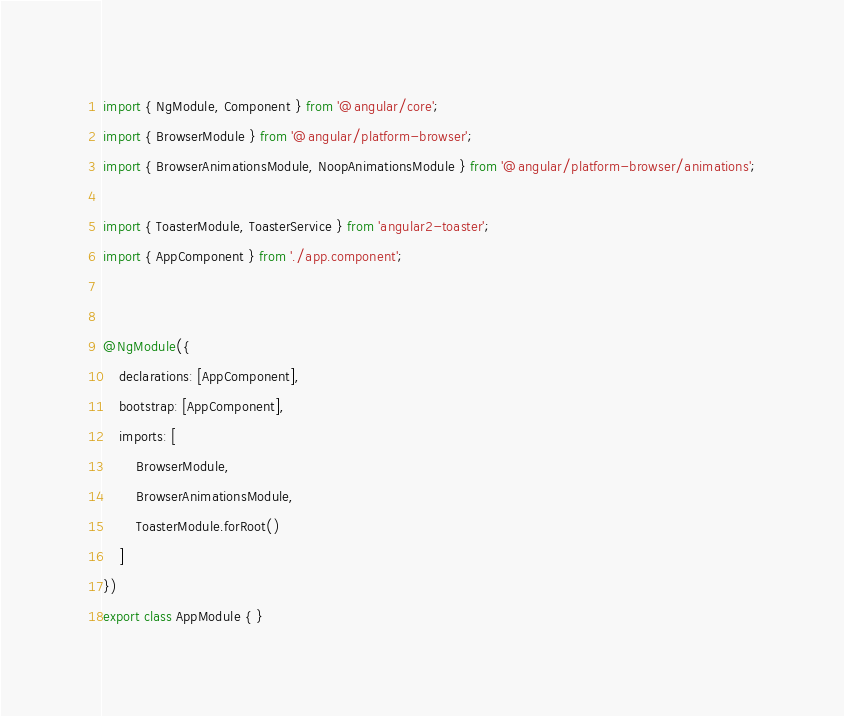<code> <loc_0><loc_0><loc_500><loc_500><_TypeScript_>import { NgModule, Component } from '@angular/core';
import { BrowserModule } from '@angular/platform-browser';
import { BrowserAnimationsModule, NoopAnimationsModule } from '@angular/platform-browser/animations';

import { ToasterModule, ToasterService } from 'angular2-toaster';
import { AppComponent } from './app.component';


@NgModule({
    declarations: [AppComponent],
    bootstrap: [AppComponent],
    imports: [
        BrowserModule,
        BrowserAnimationsModule,
        ToasterModule.forRoot()
    ]
})
export class AppModule { }
</code> 